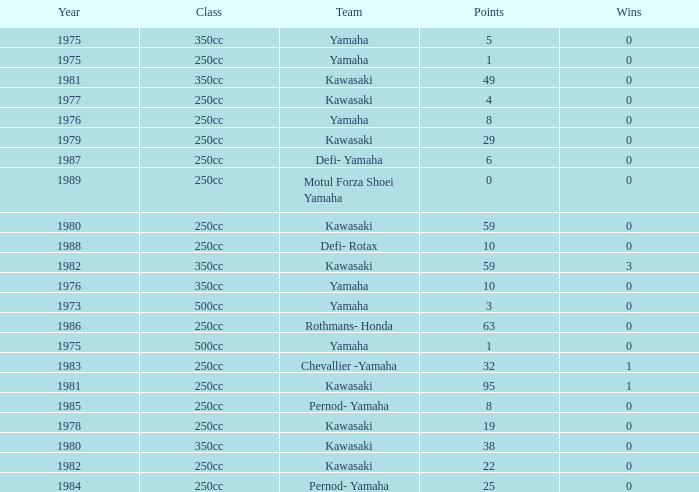Which highest wins number had Kawasaki as a team, 95 points, and a year prior to 1981? None. Would you be able to parse every entry in this table? {'header': ['Year', 'Class', 'Team', 'Points', 'Wins'], 'rows': [['1975', '350cc', 'Yamaha', '5', '0'], ['1975', '250cc', 'Yamaha', '1', '0'], ['1981', '350cc', 'Kawasaki', '49', '0'], ['1977', '250cc', 'Kawasaki', '4', '0'], ['1976', '250cc', 'Yamaha', '8', '0'], ['1979', '250cc', 'Kawasaki', '29', '0'], ['1987', '250cc', 'Defi- Yamaha', '6', '0'], ['1989', '250cc', 'Motul Forza Shoei Yamaha', '0', '0'], ['1980', '250cc', 'Kawasaki', '59', '0'], ['1988', '250cc', 'Defi- Rotax', '10', '0'], ['1982', '350cc', 'Kawasaki', '59', '3'], ['1976', '350cc', 'Yamaha', '10', '0'], ['1973', '500cc', 'Yamaha', '3', '0'], ['1986', '250cc', 'Rothmans- Honda', '63', '0'], ['1975', '500cc', 'Yamaha', '1', '0'], ['1983', '250cc', 'Chevallier -Yamaha', '32', '1'], ['1981', '250cc', 'Kawasaki', '95', '1'], ['1985', '250cc', 'Pernod- Yamaha', '8', '0'], ['1978', '250cc', 'Kawasaki', '19', '0'], ['1980', '350cc', 'Kawasaki', '38', '0'], ['1982', '250cc', 'Kawasaki', '22', '0'], ['1984', '250cc', 'Pernod- Yamaha', '25', '0']]} 